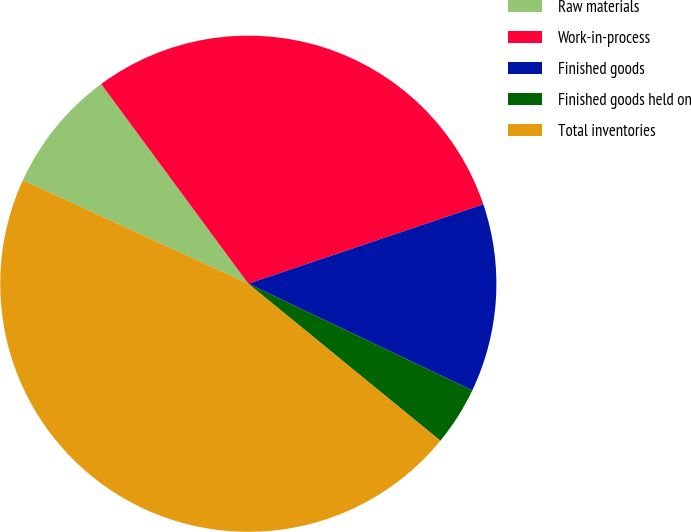Convert chart. <chart><loc_0><loc_0><loc_500><loc_500><pie_chart><fcel>Raw materials<fcel>Work-in-process<fcel>Finished goods<fcel>Finished goods held on<fcel>Total inventories<nl><fcel>8.04%<fcel>29.92%<fcel>12.26%<fcel>3.83%<fcel>45.94%<nl></chart> 